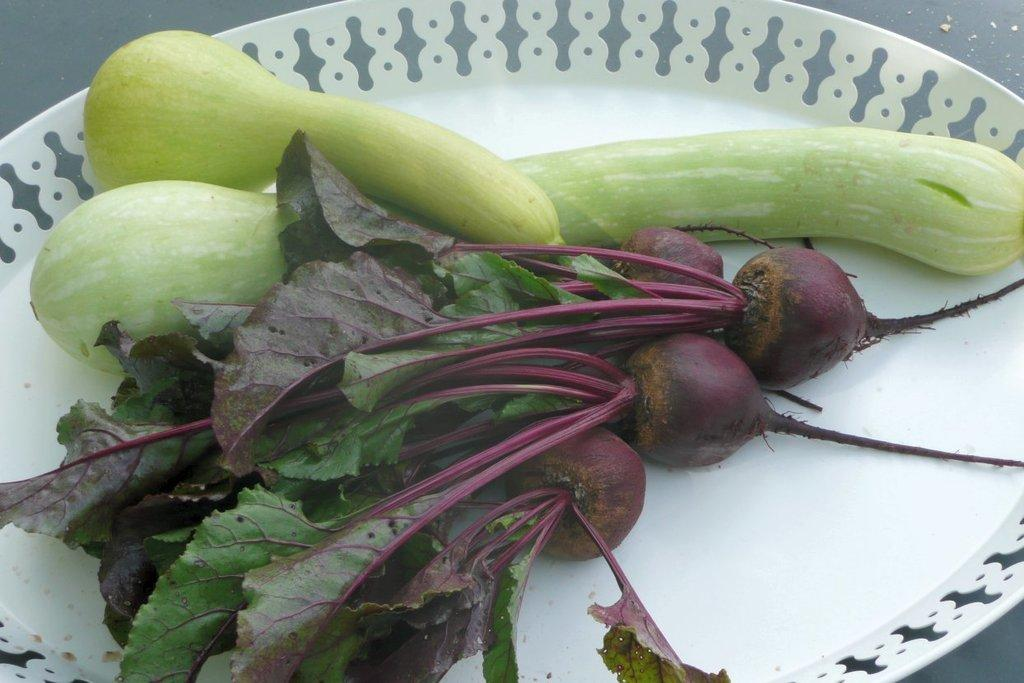What types of food can be seen in the image? There are different types of vegetables in the image. How are the vegetables arranged or presented in the image? The vegetables are on a white plate. What type of building is visible in the image? There is no building present in the image; it only features vegetables on a white plate. 